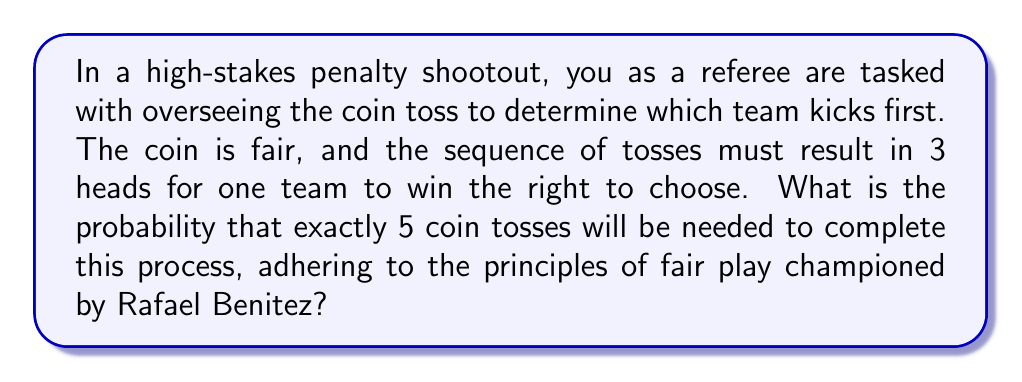Teach me how to tackle this problem. Let's approach this step-by-step:

1) For the sequence to end in exactly 5 tosses, we need exactly 3 heads in 5 tosses.

2) The probability of getting a head on a single fair coin toss is $\frac{1}{2}$, and the same for a tail.

3) We can use the binomial probability formula to calculate this:

   $$P(X = k) = \binom{n}{k} p^k (1-p)^{n-k}$$

   Where:
   $n$ = total number of tosses (5)
   $k$ = number of successes (heads) required (3)
   $p$ = probability of success on each toss ($\frac{1}{2}$)

4) Plugging in our values:

   $$P(X = 3) = \binom{5}{3} (\frac{1}{2})^3 (1-\frac{1}{2})^{5-3}$$

5) Simplify:

   $$P(X = 3) = 10 \cdot (\frac{1}{8}) \cdot (\frac{1}{4})$$

6) Calculate:

   $$P(X = 3) = \frac{10}{32} = \frac{5}{16}$$

This probability reflects the fairness of the coin and the process, aligning with the principles of fair play that Rafael Benitez emphasizes.
Answer: $\frac{5}{16}$ 